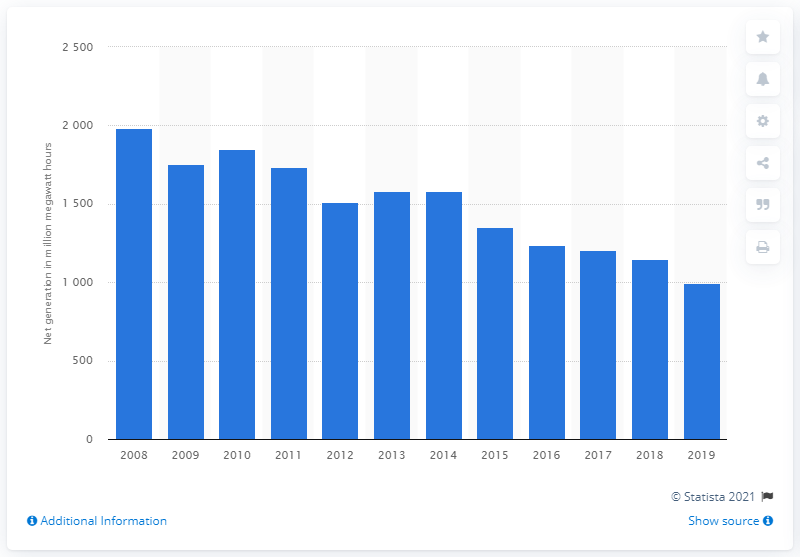Draw attention to some important aspects in this diagram. In 2019, the United States generated 996.1 megawatt hours of electricity from coal. In the previous decade, the United States generated approximately 996.1 megawatt hours of electricity from coal. 